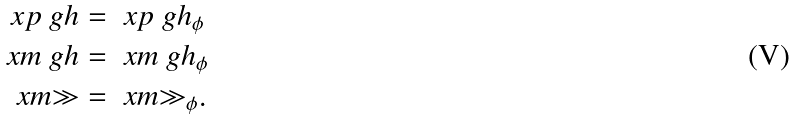<formula> <loc_0><loc_0><loc_500><loc_500>\ x p { \ g h } & = \ x p { \ g h _ { \phi } } \\ \ x m { \ g h } & = \ x m { \ g h _ { \phi } } \\ \ x m { \gg } & = \ x m { \gg _ { \phi } } .</formula> 